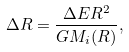<formula> <loc_0><loc_0><loc_500><loc_500>\Delta R = \frac { \Delta E R ^ { 2 } } { G M _ { i } ( R ) } ,</formula> 